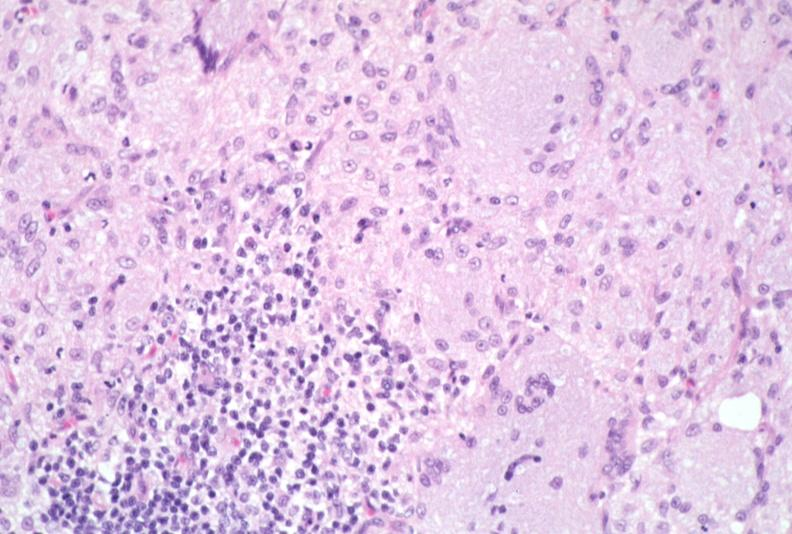does this image show lymph node, mycobacterium avium-intracellulae mai?
Answer the question using a single word or phrase. Yes 